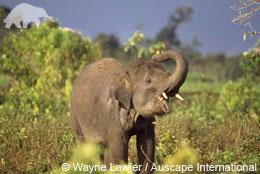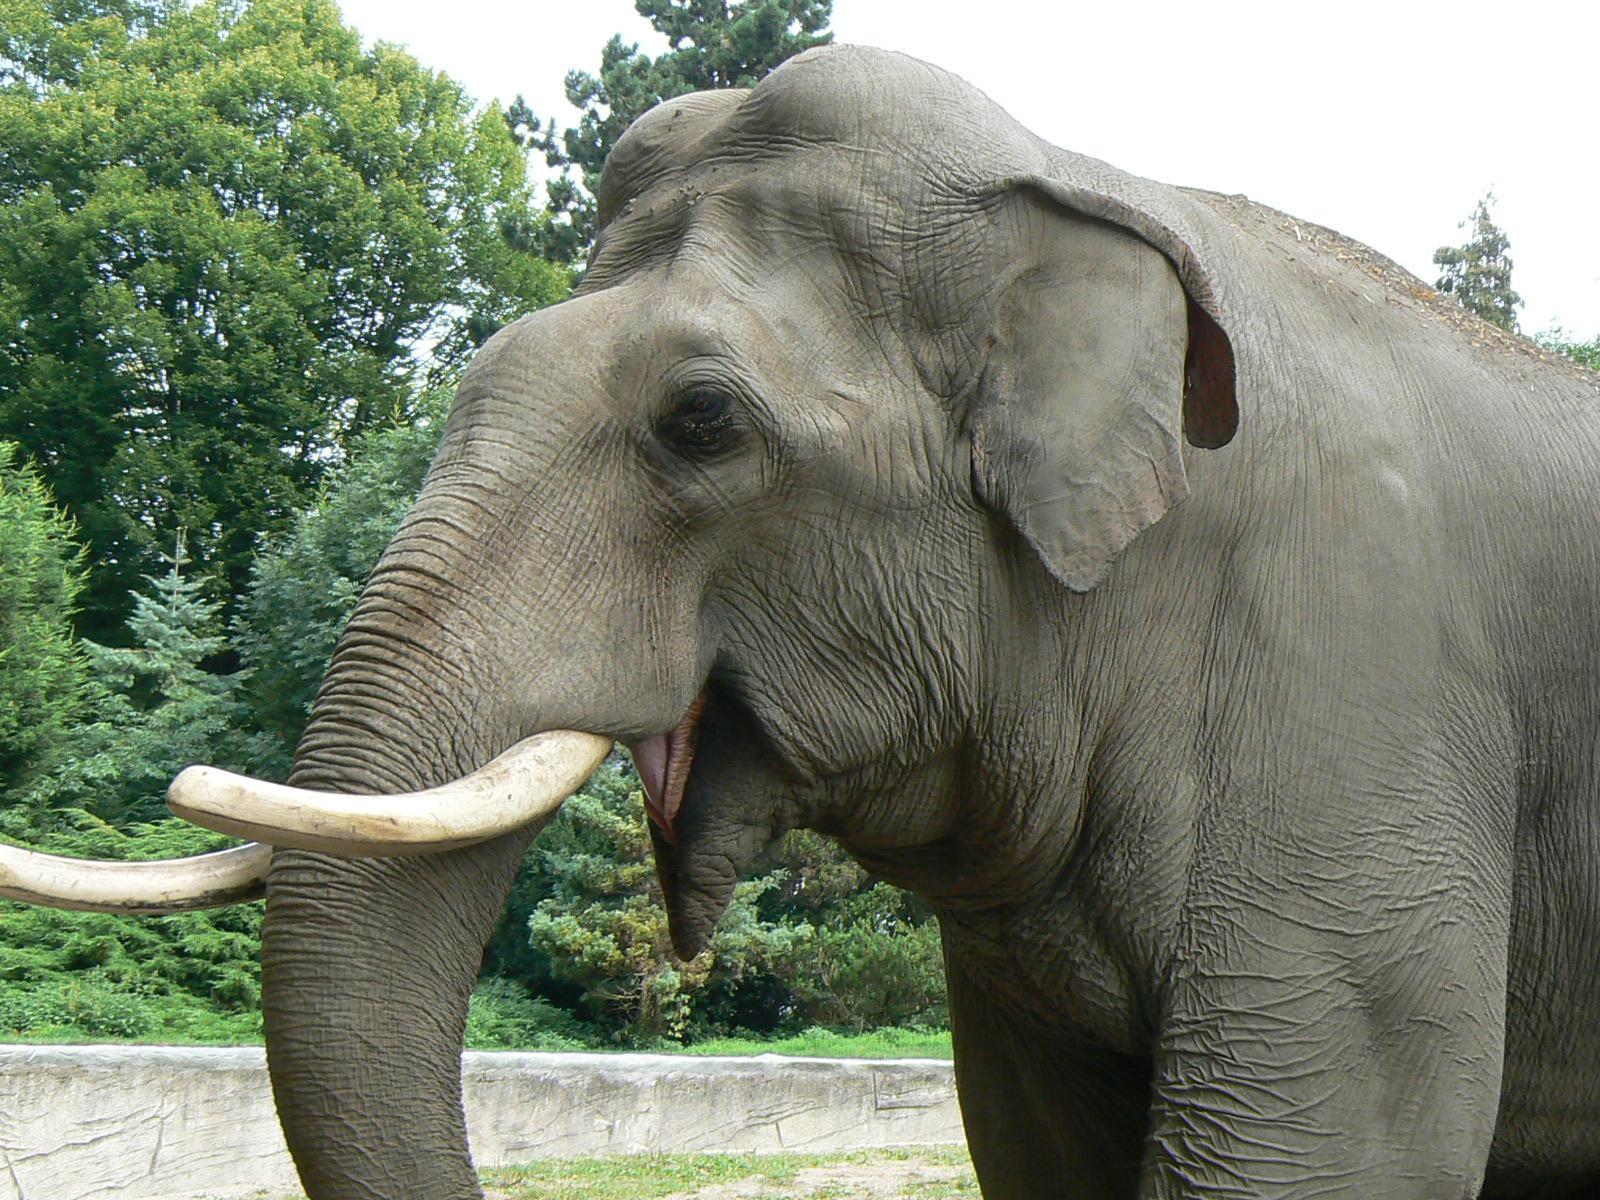The first image is the image on the left, the second image is the image on the right. For the images displayed, is the sentence "A tusked elephant stands on a concrete area in the image on the right." factually correct? Answer yes or no. No. 